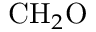Convert formula to latex. <formula><loc_0><loc_0><loc_500><loc_500>C H _ { 2 } O</formula> 